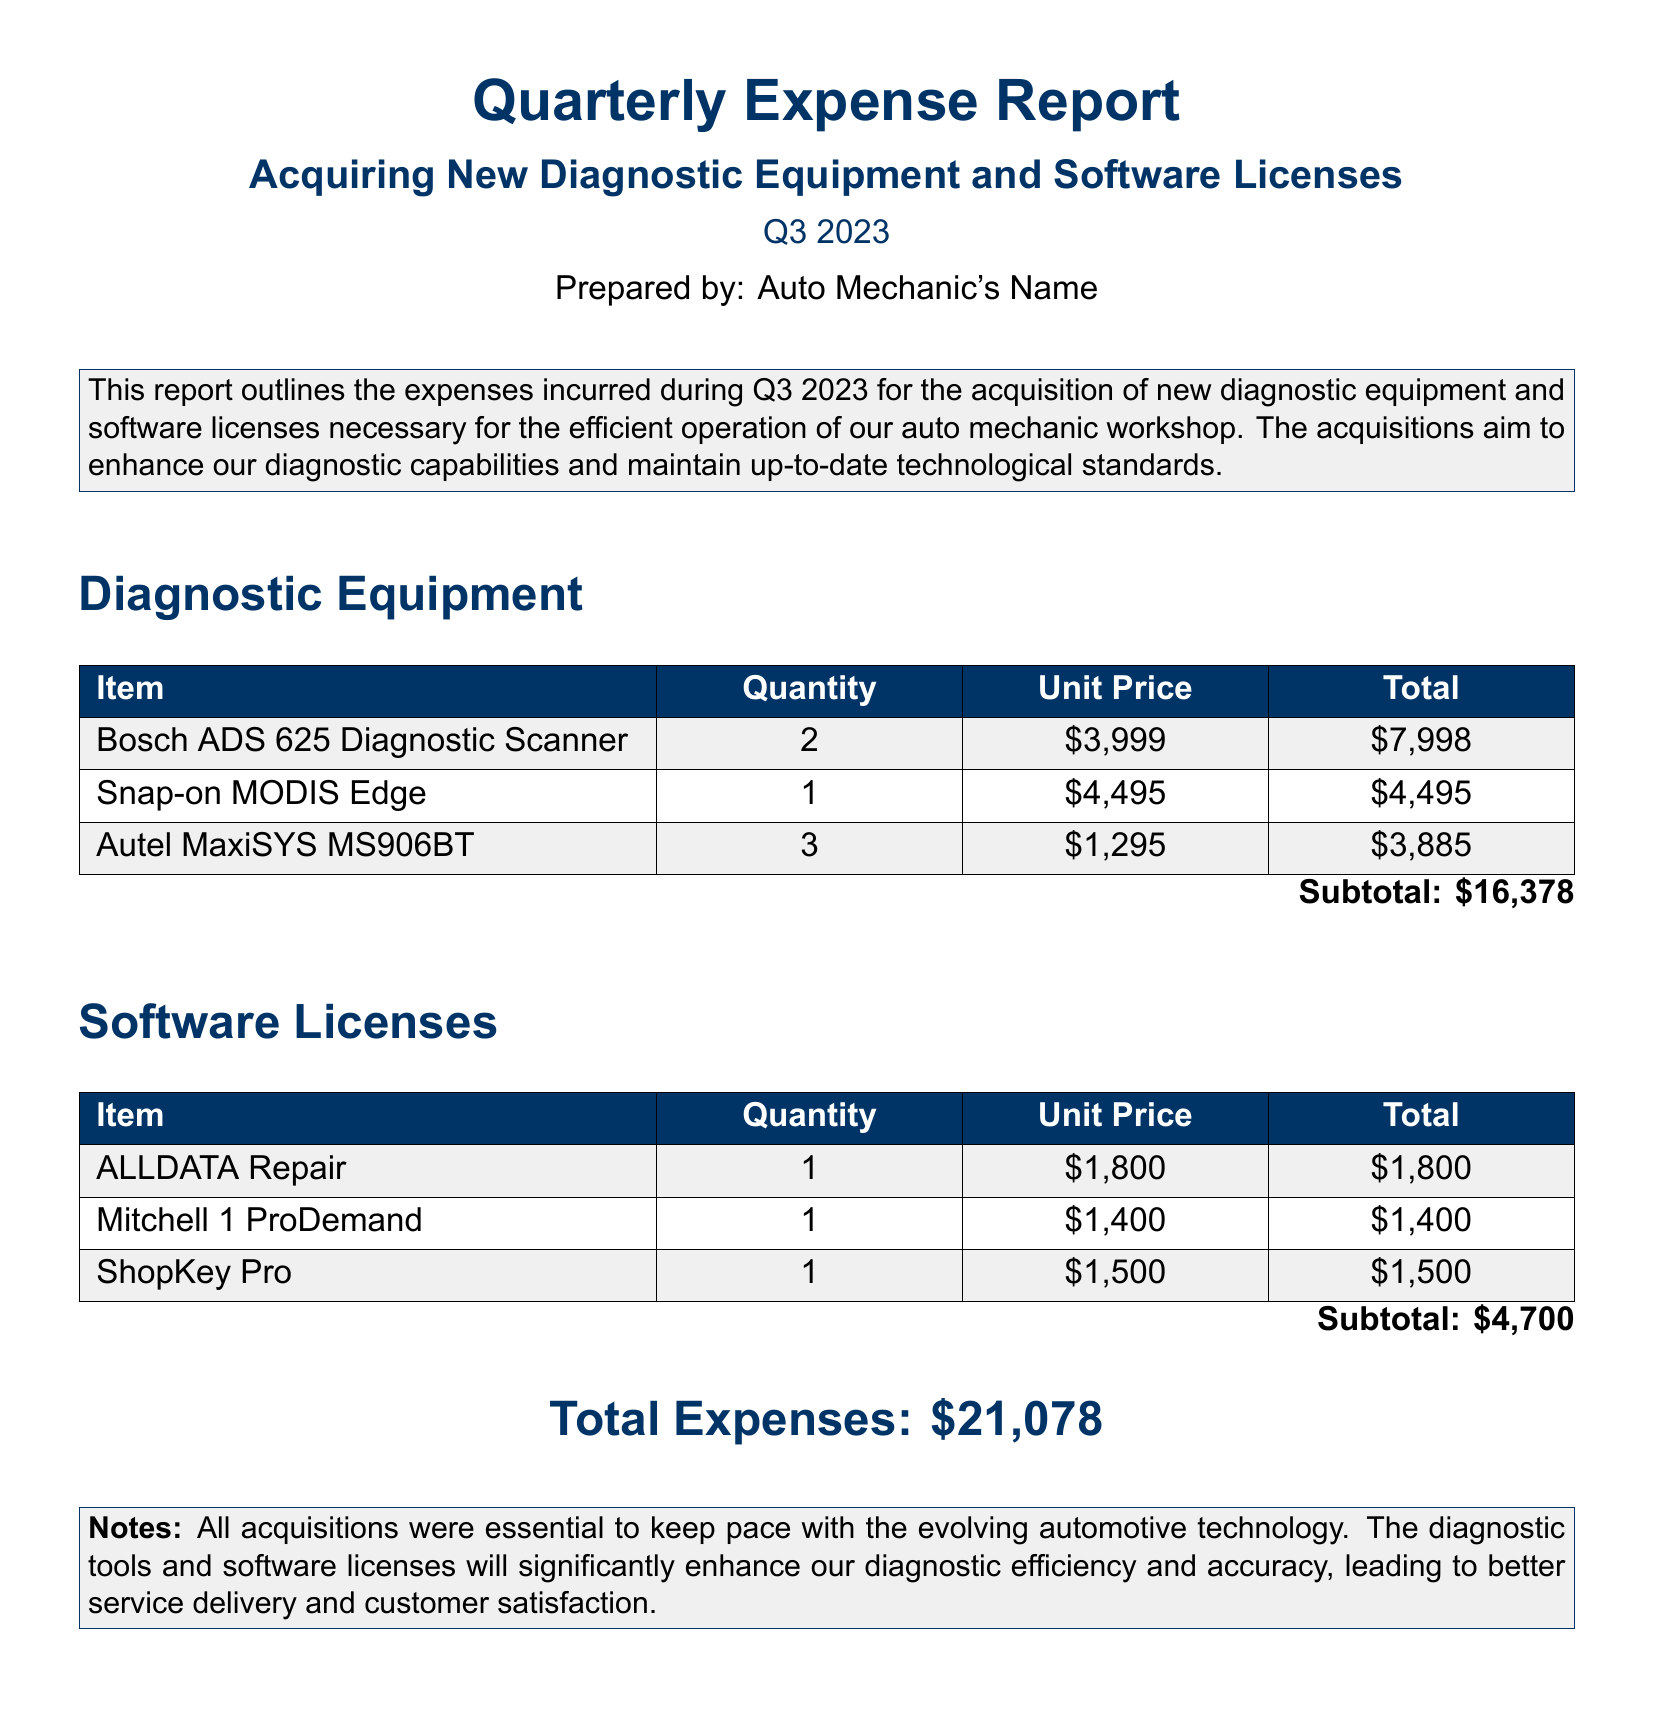What is the total expense for acquiring diagnostic equipment? The total expense for diagnostic equipment is found in the subtotal section of the report, which is $16,378.
Answer: $16,378 How many Snap-on MODIS Edge scanners were purchased? The document specifies the quantity of the Snap-on MODIS Edge scanners in the diagnostic equipment section as 1.
Answer: 1 What is the unit price of the Bosch ADS 625 Diagnostic Scanner? The unit price is listed in the table of diagnostic equipment, which shows $3,999.
Answer: $3,999 What is the subtotal for software licenses? The subtotal for software licenses is included in the summary of the software section, which totals $4,700.
Answer: $4,700 What was the total expenses incurred during Q3 2023? The total expenses are provided at the end of the document and are the sum of all acquisitions, which is $21,078.
Answer: $21,078 How many Autel MaxiSYS MS906BT scanners were acquired? The quantity of the Autel MaxiSYS MS906BT scanners is recorded in the equipment table as 3.
Answer: 3 What type of report is this document? The title of the document indicates that it is a quarterly expense report.
Answer: Quarterly expense report Which software license cost the most? The software license with the highest cost is indicated in the software licensing table as ALLDATA Repair at $1,800.
Answer: ALLDATA Repair How many items are listed under diagnostic equipment in total? The document includes three different items listed in the diagnostic equipment section.
Answer: 3 